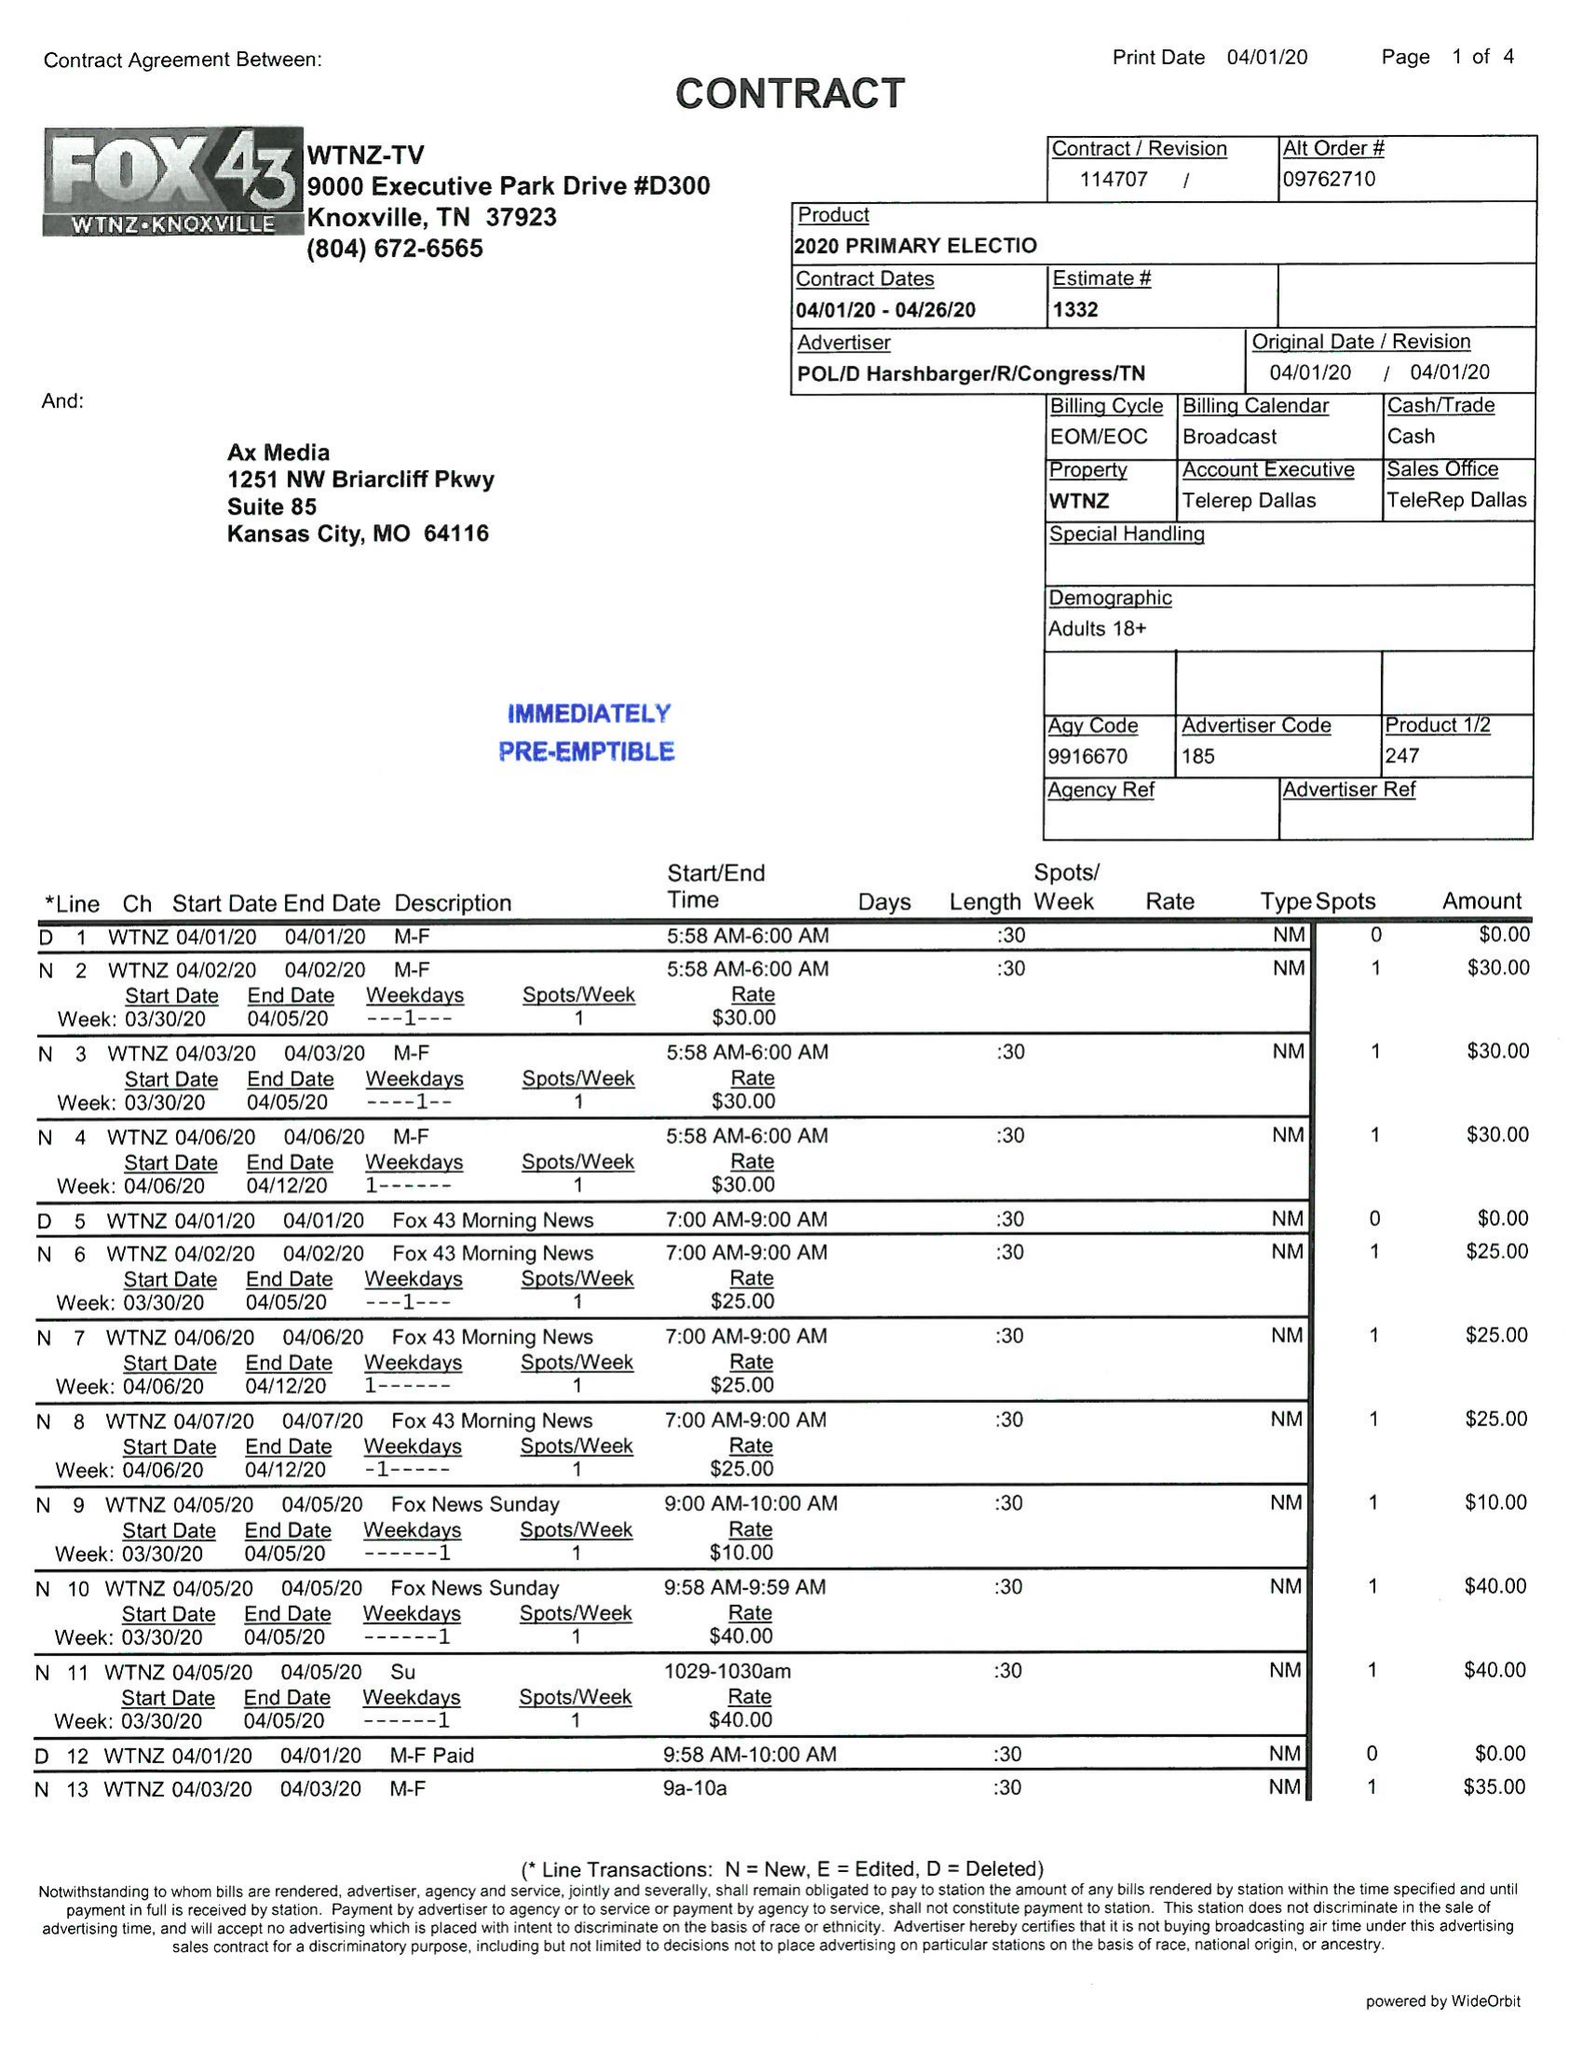What is the value for the contract_num?
Answer the question using a single word or phrase. 114707 